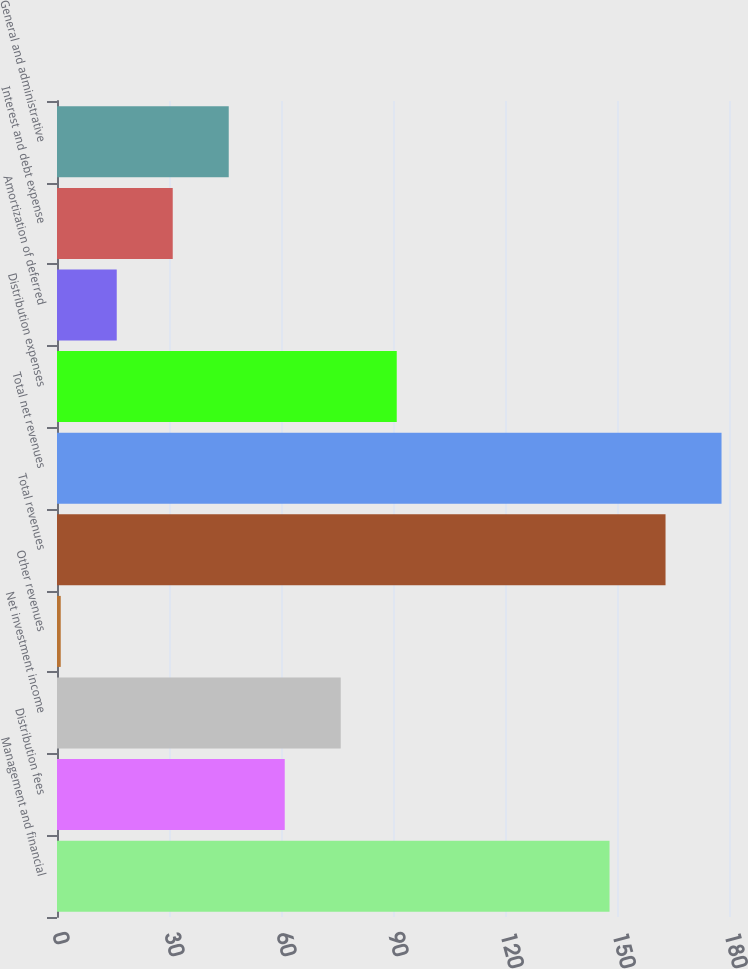Convert chart to OTSL. <chart><loc_0><loc_0><loc_500><loc_500><bar_chart><fcel>Management and financial<fcel>Distribution fees<fcel>Net investment income<fcel>Other revenues<fcel>Total revenues<fcel>Total net revenues<fcel>Distribution expenses<fcel>Amortization of deferred<fcel>Interest and debt expense<fcel>General and administrative<nl><fcel>148<fcel>61<fcel>76<fcel>1<fcel>163<fcel>178<fcel>91<fcel>16<fcel>31<fcel>46<nl></chart> 